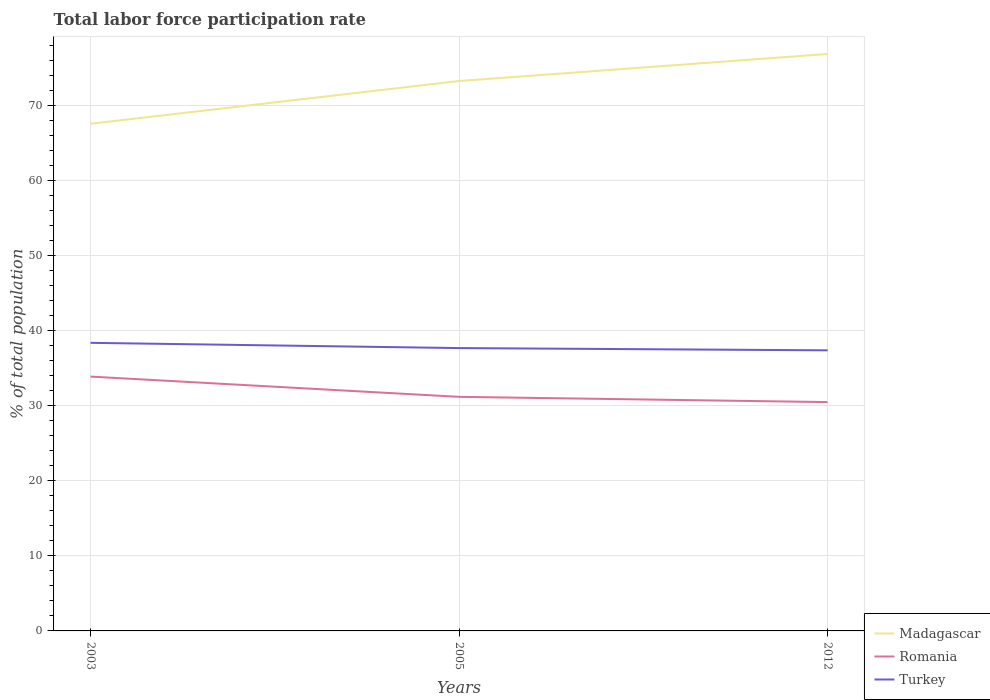Across all years, what is the maximum total labor force participation rate in Turkey?
Make the answer very short. 37.4. What is the total total labor force participation rate in Turkey in the graph?
Provide a succinct answer. 0.3. What is the difference between the highest and the second highest total labor force participation rate in Romania?
Ensure brevity in your answer.  3.4. How many lines are there?
Your answer should be very brief. 3. How many years are there in the graph?
Ensure brevity in your answer.  3. What is the difference between two consecutive major ticks on the Y-axis?
Your response must be concise. 10. Are the values on the major ticks of Y-axis written in scientific E-notation?
Offer a terse response. No. Does the graph contain grids?
Ensure brevity in your answer.  Yes. Where does the legend appear in the graph?
Give a very brief answer. Bottom right. How many legend labels are there?
Keep it short and to the point. 3. What is the title of the graph?
Keep it short and to the point. Total labor force participation rate. What is the label or title of the X-axis?
Make the answer very short. Years. What is the label or title of the Y-axis?
Offer a terse response. % of total population. What is the % of total population of Madagascar in 2003?
Offer a very short reply. 67.6. What is the % of total population of Romania in 2003?
Ensure brevity in your answer.  33.9. What is the % of total population of Turkey in 2003?
Your answer should be compact. 38.4. What is the % of total population in Madagascar in 2005?
Your answer should be compact. 73.3. What is the % of total population of Romania in 2005?
Your answer should be very brief. 31.2. What is the % of total population in Turkey in 2005?
Keep it short and to the point. 37.7. What is the % of total population of Madagascar in 2012?
Your answer should be compact. 76.9. What is the % of total population in Romania in 2012?
Make the answer very short. 30.5. What is the % of total population in Turkey in 2012?
Your response must be concise. 37.4. Across all years, what is the maximum % of total population in Madagascar?
Make the answer very short. 76.9. Across all years, what is the maximum % of total population in Romania?
Provide a succinct answer. 33.9. Across all years, what is the maximum % of total population in Turkey?
Make the answer very short. 38.4. Across all years, what is the minimum % of total population of Madagascar?
Your answer should be very brief. 67.6. Across all years, what is the minimum % of total population in Romania?
Offer a terse response. 30.5. Across all years, what is the minimum % of total population of Turkey?
Make the answer very short. 37.4. What is the total % of total population in Madagascar in the graph?
Provide a short and direct response. 217.8. What is the total % of total population in Romania in the graph?
Provide a succinct answer. 95.6. What is the total % of total population of Turkey in the graph?
Keep it short and to the point. 113.5. What is the difference between the % of total population in Turkey in 2003 and that in 2005?
Ensure brevity in your answer.  0.7. What is the difference between the % of total population of Turkey in 2003 and that in 2012?
Offer a very short reply. 1. What is the difference between the % of total population in Madagascar in 2005 and that in 2012?
Provide a succinct answer. -3.6. What is the difference between the % of total population of Romania in 2005 and that in 2012?
Keep it short and to the point. 0.7. What is the difference between the % of total population of Madagascar in 2003 and the % of total population of Romania in 2005?
Your response must be concise. 36.4. What is the difference between the % of total population in Madagascar in 2003 and the % of total population in Turkey in 2005?
Provide a succinct answer. 29.9. What is the difference between the % of total population in Romania in 2003 and the % of total population in Turkey in 2005?
Your response must be concise. -3.8. What is the difference between the % of total population in Madagascar in 2003 and the % of total population in Romania in 2012?
Offer a very short reply. 37.1. What is the difference between the % of total population in Madagascar in 2003 and the % of total population in Turkey in 2012?
Make the answer very short. 30.2. What is the difference between the % of total population in Romania in 2003 and the % of total population in Turkey in 2012?
Offer a very short reply. -3.5. What is the difference between the % of total population in Madagascar in 2005 and the % of total population in Romania in 2012?
Your answer should be compact. 42.8. What is the difference between the % of total population in Madagascar in 2005 and the % of total population in Turkey in 2012?
Provide a short and direct response. 35.9. What is the difference between the % of total population of Romania in 2005 and the % of total population of Turkey in 2012?
Keep it short and to the point. -6.2. What is the average % of total population in Madagascar per year?
Offer a terse response. 72.6. What is the average % of total population of Romania per year?
Give a very brief answer. 31.87. What is the average % of total population in Turkey per year?
Offer a very short reply. 37.83. In the year 2003, what is the difference between the % of total population in Madagascar and % of total population in Romania?
Offer a very short reply. 33.7. In the year 2003, what is the difference between the % of total population of Madagascar and % of total population of Turkey?
Provide a short and direct response. 29.2. In the year 2005, what is the difference between the % of total population of Madagascar and % of total population of Romania?
Offer a very short reply. 42.1. In the year 2005, what is the difference between the % of total population in Madagascar and % of total population in Turkey?
Make the answer very short. 35.6. In the year 2005, what is the difference between the % of total population in Romania and % of total population in Turkey?
Give a very brief answer. -6.5. In the year 2012, what is the difference between the % of total population of Madagascar and % of total population of Romania?
Keep it short and to the point. 46.4. In the year 2012, what is the difference between the % of total population of Madagascar and % of total population of Turkey?
Your answer should be very brief. 39.5. What is the ratio of the % of total population in Madagascar in 2003 to that in 2005?
Your response must be concise. 0.92. What is the ratio of the % of total population in Romania in 2003 to that in 2005?
Make the answer very short. 1.09. What is the ratio of the % of total population in Turkey in 2003 to that in 2005?
Give a very brief answer. 1.02. What is the ratio of the % of total population in Madagascar in 2003 to that in 2012?
Your answer should be very brief. 0.88. What is the ratio of the % of total population of Romania in 2003 to that in 2012?
Your answer should be very brief. 1.11. What is the ratio of the % of total population in Turkey in 2003 to that in 2012?
Your response must be concise. 1.03. What is the ratio of the % of total population in Madagascar in 2005 to that in 2012?
Provide a short and direct response. 0.95. What is the ratio of the % of total population in Romania in 2005 to that in 2012?
Offer a very short reply. 1.02. What is the ratio of the % of total population in Turkey in 2005 to that in 2012?
Offer a terse response. 1.01. What is the difference between the highest and the second highest % of total population of Madagascar?
Your answer should be very brief. 3.6. What is the difference between the highest and the second highest % of total population of Turkey?
Give a very brief answer. 0.7. What is the difference between the highest and the lowest % of total population of Romania?
Your answer should be very brief. 3.4. 